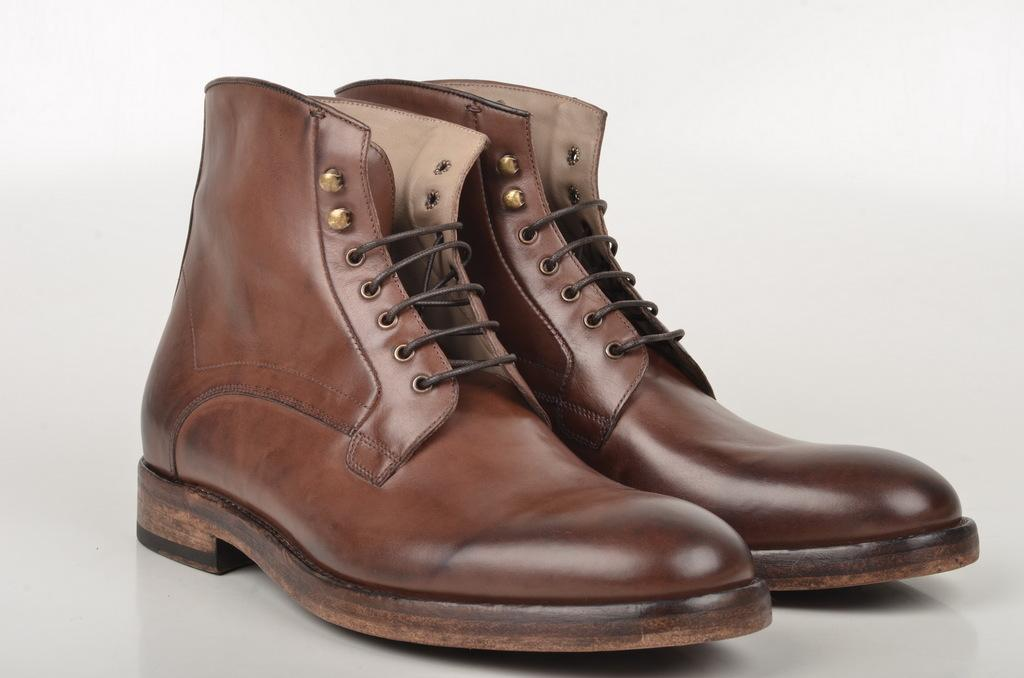What objects are on a platform in the image? There are shoes on a platform in the image. Can you describe the shoes on the platform? Unfortunately, the facts provided do not give any details about the shoes. What is the purpose of the platform in the image? The purpose of the platform is not specified in the facts provided. What type of print can be seen on the metal leg in the image? There is no mention of a metal leg or any print in the image. 